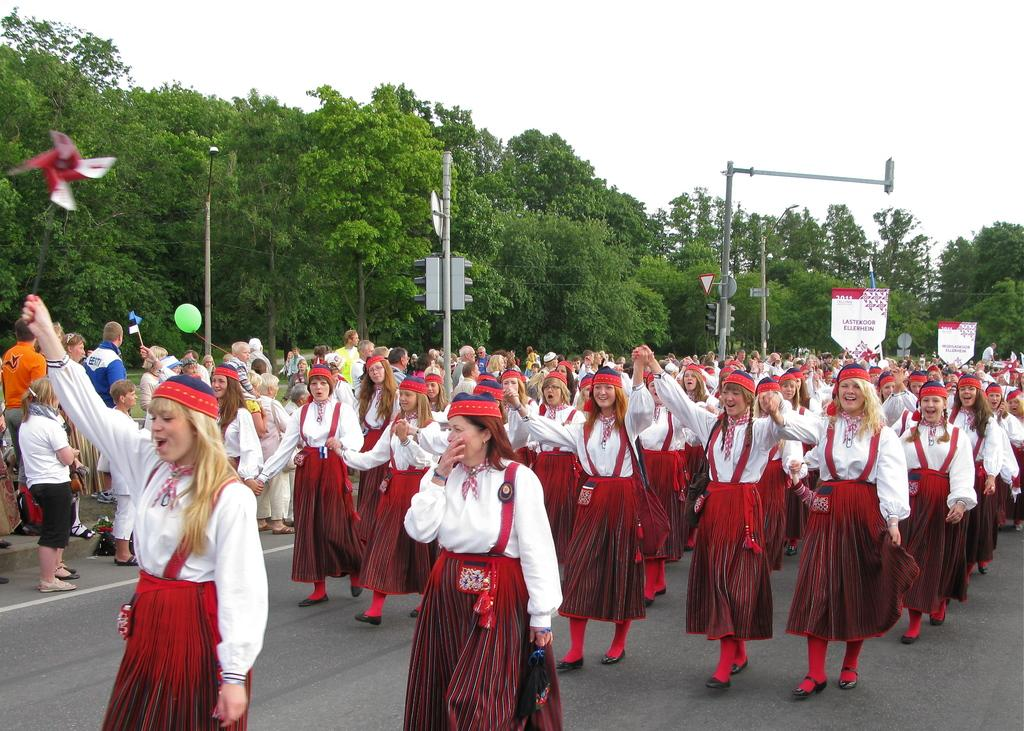What are the women in the foreground of the picture wearing? The women in the foreground of the picture are wearing white and red costumes. What can be seen in the background of the picture? In the background of the picture, there are signal lights, poles, trees, and a cloudy sky. Where are the people located in the picture? The people are on the left side of the picture. What type of brass instrument is being played by the women in the picture? There is no brass instrument visible in the picture; the women are wearing costumes. Is it raining in the picture? There is no indication of rain in the picture, as the sky is cloudy but not raining. 